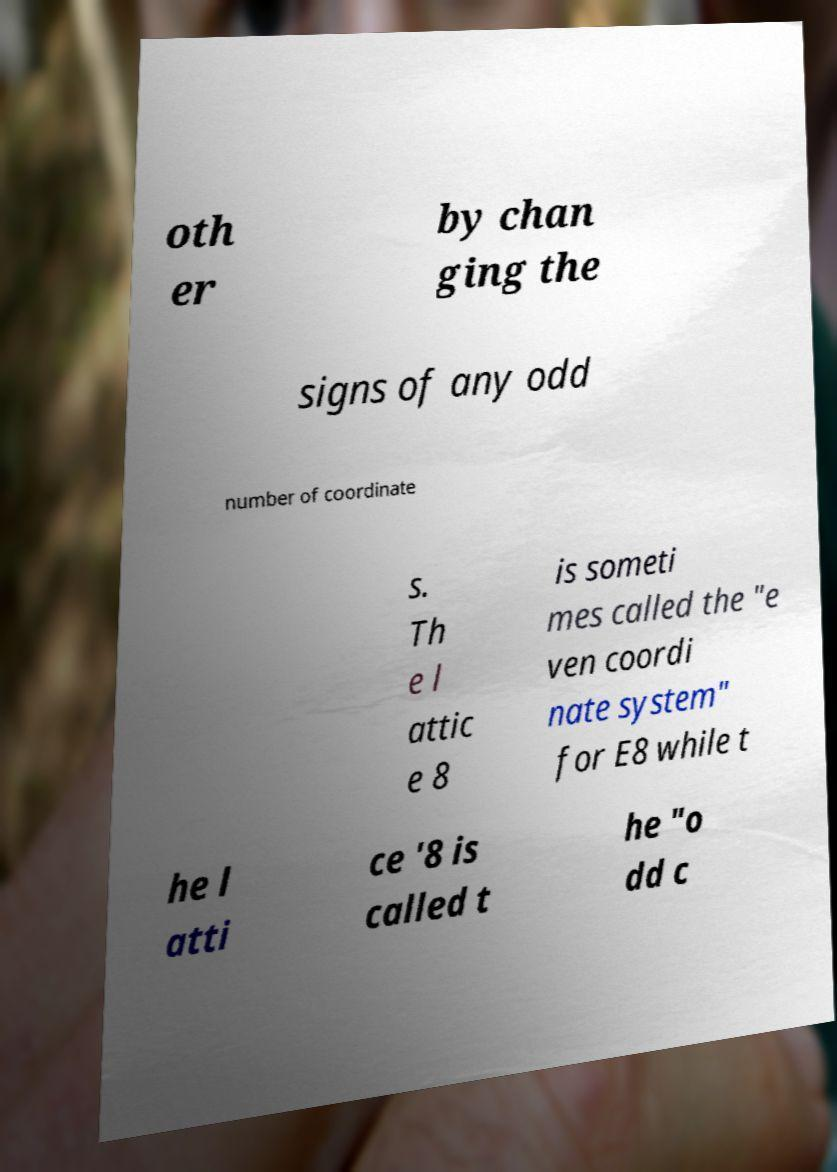There's text embedded in this image that I need extracted. Can you transcribe it verbatim? oth er by chan ging the signs of any odd number of coordinate s. Th e l attic e 8 is someti mes called the "e ven coordi nate system" for E8 while t he l atti ce '8 is called t he "o dd c 